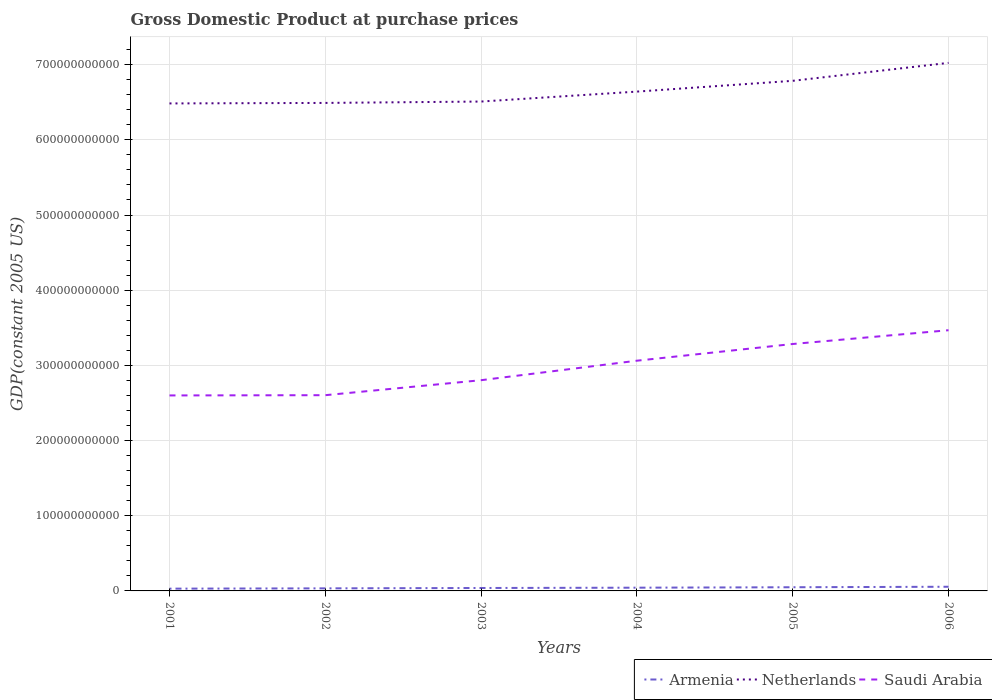Across all years, what is the maximum GDP at purchase prices in Armenia?
Make the answer very short. 3.02e+09. What is the total GDP at purchase prices in Armenia in the graph?
Offer a terse response. -8.87e+08. What is the difference between the highest and the second highest GDP at purchase prices in Saudi Arabia?
Provide a short and direct response. 8.68e+1. Is the GDP at purchase prices in Netherlands strictly greater than the GDP at purchase prices in Armenia over the years?
Ensure brevity in your answer.  No. How many lines are there?
Keep it short and to the point. 3. How many years are there in the graph?
Your response must be concise. 6. What is the difference between two consecutive major ticks on the Y-axis?
Keep it short and to the point. 1.00e+11. Does the graph contain any zero values?
Offer a terse response. No. Does the graph contain grids?
Provide a succinct answer. Yes. How many legend labels are there?
Your response must be concise. 3. How are the legend labels stacked?
Offer a very short reply. Horizontal. What is the title of the graph?
Give a very brief answer. Gross Domestic Product at purchase prices. Does "Japan" appear as one of the legend labels in the graph?
Your answer should be very brief. No. What is the label or title of the Y-axis?
Ensure brevity in your answer.  GDP(constant 2005 US). What is the GDP(constant 2005 US) in Armenia in 2001?
Make the answer very short. 3.02e+09. What is the GDP(constant 2005 US) in Netherlands in 2001?
Keep it short and to the point. 6.48e+11. What is the GDP(constant 2005 US) of Saudi Arabia in 2001?
Your answer should be compact. 2.60e+11. What is the GDP(constant 2005 US) of Armenia in 2002?
Your response must be concise. 3.42e+09. What is the GDP(constant 2005 US) in Netherlands in 2002?
Provide a short and direct response. 6.49e+11. What is the GDP(constant 2005 US) in Saudi Arabia in 2002?
Offer a very short reply. 2.60e+11. What is the GDP(constant 2005 US) of Armenia in 2003?
Provide a short and direct response. 3.90e+09. What is the GDP(constant 2005 US) of Netherlands in 2003?
Keep it short and to the point. 6.51e+11. What is the GDP(constant 2005 US) in Saudi Arabia in 2003?
Provide a short and direct response. 2.80e+11. What is the GDP(constant 2005 US) in Armenia in 2004?
Provide a short and direct response. 4.30e+09. What is the GDP(constant 2005 US) in Netherlands in 2004?
Your answer should be compact. 6.64e+11. What is the GDP(constant 2005 US) of Saudi Arabia in 2004?
Make the answer very short. 3.06e+11. What is the GDP(constant 2005 US) in Armenia in 2005?
Provide a succinct answer. 4.90e+09. What is the GDP(constant 2005 US) in Netherlands in 2005?
Keep it short and to the point. 6.79e+11. What is the GDP(constant 2005 US) in Saudi Arabia in 2005?
Offer a very short reply. 3.28e+11. What is the GDP(constant 2005 US) in Armenia in 2006?
Your answer should be very brief. 5.55e+09. What is the GDP(constant 2005 US) of Netherlands in 2006?
Give a very brief answer. 7.02e+11. What is the GDP(constant 2005 US) of Saudi Arabia in 2006?
Offer a very short reply. 3.47e+11. Across all years, what is the maximum GDP(constant 2005 US) of Armenia?
Your response must be concise. 5.55e+09. Across all years, what is the maximum GDP(constant 2005 US) of Netherlands?
Keep it short and to the point. 7.02e+11. Across all years, what is the maximum GDP(constant 2005 US) in Saudi Arabia?
Give a very brief answer. 3.47e+11. Across all years, what is the minimum GDP(constant 2005 US) in Armenia?
Provide a succinct answer. 3.02e+09. Across all years, what is the minimum GDP(constant 2005 US) of Netherlands?
Provide a short and direct response. 6.48e+11. Across all years, what is the minimum GDP(constant 2005 US) of Saudi Arabia?
Provide a short and direct response. 2.60e+11. What is the total GDP(constant 2005 US) of Armenia in the graph?
Provide a short and direct response. 2.51e+1. What is the total GDP(constant 2005 US) of Netherlands in the graph?
Ensure brevity in your answer.  3.99e+12. What is the total GDP(constant 2005 US) of Saudi Arabia in the graph?
Your answer should be very brief. 1.78e+12. What is the difference between the GDP(constant 2005 US) in Armenia in 2001 and that in 2002?
Your response must be concise. -3.98e+08. What is the difference between the GDP(constant 2005 US) in Netherlands in 2001 and that in 2002?
Ensure brevity in your answer.  -6.72e+08. What is the difference between the GDP(constant 2005 US) in Saudi Arabia in 2001 and that in 2002?
Provide a succinct answer. -3.32e+08. What is the difference between the GDP(constant 2005 US) of Armenia in 2001 and that in 2003?
Your answer should be very brief. -8.78e+08. What is the difference between the GDP(constant 2005 US) in Netherlands in 2001 and that in 2003?
Keep it short and to the point. -2.51e+09. What is the difference between the GDP(constant 2005 US) in Saudi Arabia in 2001 and that in 2003?
Your response must be concise. -2.03e+1. What is the difference between the GDP(constant 2005 US) in Armenia in 2001 and that in 2004?
Provide a short and direct response. -1.29e+09. What is the difference between the GDP(constant 2005 US) of Netherlands in 2001 and that in 2004?
Ensure brevity in your answer.  -1.57e+1. What is the difference between the GDP(constant 2005 US) in Saudi Arabia in 2001 and that in 2004?
Your answer should be very brief. -4.62e+1. What is the difference between the GDP(constant 2005 US) in Armenia in 2001 and that in 2005?
Make the answer very short. -1.88e+09. What is the difference between the GDP(constant 2005 US) of Netherlands in 2001 and that in 2005?
Your answer should be compact. -3.01e+1. What is the difference between the GDP(constant 2005 US) in Saudi Arabia in 2001 and that in 2005?
Your answer should be very brief. -6.84e+1. What is the difference between the GDP(constant 2005 US) in Armenia in 2001 and that in 2006?
Offer a terse response. -2.53e+09. What is the difference between the GDP(constant 2005 US) in Netherlands in 2001 and that in 2006?
Make the answer very short. -5.40e+1. What is the difference between the GDP(constant 2005 US) in Saudi Arabia in 2001 and that in 2006?
Offer a terse response. -8.68e+1. What is the difference between the GDP(constant 2005 US) of Armenia in 2002 and that in 2003?
Make the answer very short. -4.80e+08. What is the difference between the GDP(constant 2005 US) of Netherlands in 2002 and that in 2003?
Provide a succinct answer. -1.84e+09. What is the difference between the GDP(constant 2005 US) in Saudi Arabia in 2002 and that in 2003?
Ensure brevity in your answer.  -1.99e+1. What is the difference between the GDP(constant 2005 US) in Armenia in 2002 and that in 2004?
Keep it short and to the point. -8.87e+08. What is the difference between the GDP(constant 2005 US) of Netherlands in 2002 and that in 2004?
Provide a succinct answer. -1.51e+1. What is the difference between the GDP(constant 2005 US) of Saudi Arabia in 2002 and that in 2004?
Give a very brief answer. -4.59e+1. What is the difference between the GDP(constant 2005 US) in Armenia in 2002 and that in 2005?
Give a very brief answer. -1.48e+09. What is the difference between the GDP(constant 2005 US) in Netherlands in 2002 and that in 2005?
Your response must be concise. -2.94e+1. What is the difference between the GDP(constant 2005 US) of Saudi Arabia in 2002 and that in 2005?
Offer a terse response. -6.81e+1. What is the difference between the GDP(constant 2005 US) in Armenia in 2002 and that in 2006?
Offer a terse response. -2.13e+09. What is the difference between the GDP(constant 2005 US) in Netherlands in 2002 and that in 2006?
Keep it short and to the point. -5.33e+1. What is the difference between the GDP(constant 2005 US) in Saudi Arabia in 2002 and that in 2006?
Offer a terse response. -8.64e+1. What is the difference between the GDP(constant 2005 US) in Armenia in 2003 and that in 2004?
Your answer should be compact. -4.08e+08. What is the difference between the GDP(constant 2005 US) of Netherlands in 2003 and that in 2004?
Keep it short and to the point. -1.32e+1. What is the difference between the GDP(constant 2005 US) in Saudi Arabia in 2003 and that in 2004?
Your answer should be compact. -2.59e+1. What is the difference between the GDP(constant 2005 US) in Armenia in 2003 and that in 2005?
Give a very brief answer. -1.00e+09. What is the difference between the GDP(constant 2005 US) in Netherlands in 2003 and that in 2005?
Your answer should be compact. -2.76e+1. What is the difference between the GDP(constant 2005 US) in Saudi Arabia in 2003 and that in 2005?
Your answer should be compact. -4.82e+1. What is the difference between the GDP(constant 2005 US) in Armenia in 2003 and that in 2006?
Make the answer very short. -1.65e+09. What is the difference between the GDP(constant 2005 US) of Netherlands in 2003 and that in 2006?
Your answer should be very brief. -5.14e+1. What is the difference between the GDP(constant 2005 US) of Saudi Arabia in 2003 and that in 2006?
Your answer should be very brief. -6.65e+1. What is the difference between the GDP(constant 2005 US) in Armenia in 2004 and that in 2005?
Offer a terse response. -5.97e+08. What is the difference between the GDP(constant 2005 US) in Netherlands in 2004 and that in 2005?
Your answer should be very brief. -1.43e+1. What is the difference between the GDP(constant 2005 US) in Saudi Arabia in 2004 and that in 2005?
Your response must be concise. -2.22e+1. What is the difference between the GDP(constant 2005 US) in Armenia in 2004 and that in 2006?
Your response must be concise. -1.24e+09. What is the difference between the GDP(constant 2005 US) of Netherlands in 2004 and that in 2006?
Keep it short and to the point. -3.82e+1. What is the difference between the GDP(constant 2005 US) in Saudi Arabia in 2004 and that in 2006?
Provide a succinct answer. -4.05e+1. What is the difference between the GDP(constant 2005 US) of Armenia in 2005 and that in 2006?
Give a very brief answer. -6.47e+08. What is the difference between the GDP(constant 2005 US) in Netherlands in 2005 and that in 2006?
Keep it short and to the point. -2.39e+1. What is the difference between the GDP(constant 2005 US) in Saudi Arabia in 2005 and that in 2006?
Provide a succinct answer. -1.83e+1. What is the difference between the GDP(constant 2005 US) of Armenia in 2001 and the GDP(constant 2005 US) of Netherlands in 2002?
Give a very brief answer. -6.46e+11. What is the difference between the GDP(constant 2005 US) in Armenia in 2001 and the GDP(constant 2005 US) in Saudi Arabia in 2002?
Provide a short and direct response. -2.57e+11. What is the difference between the GDP(constant 2005 US) in Netherlands in 2001 and the GDP(constant 2005 US) in Saudi Arabia in 2002?
Your answer should be very brief. 3.88e+11. What is the difference between the GDP(constant 2005 US) in Armenia in 2001 and the GDP(constant 2005 US) in Netherlands in 2003?
Offer a terse response. -6.48e+11. What is the difference between the GDP(constant 2005 US) in Armenia in 2001 and the GDP(constant 2005 US) in Saudi Arabia in 2003?
Ensure brevity in your answer.  -2.77e+11. What is the difference between the GDP(constant 2005 US) of Netherlands in 2001 and the GDP(constant 2005 US) of Saudi Arabia in 2003?
Provide a short and direct response. 3.68e+11. What is the difference between the GDP(constant 2005 US) of Armenia in 2001 and the GDP(constant 2005 US) of Netherlands in 2004?
Make the answer very short. -6.61e+11. What is the difference between the GDP(constant 2005 US) of Armenia in 2001 and the GDP(constant 2005 US) of Saudi Arabia in 2004?
Your answer should be compact. -3.03e+11. What is the difference between the GDP(constant 2005 US) of Netherlands in 2001 and the GDP(constant 2005 US) of Saudi Arabia in 2004?
Make the answer very short. 3.42e+11. What is the difference between the GDP(constant 2005 US) in Armenia in 2001 and the GDP(constant 2005 US) in Netherlands in 2005?
Give a very brief answer. -6.76e+11. What is the difference between the GDP(constant 2005 US) in Armenia in 2001 and the GDP(constant 2005 US) in Saudi Arabia in 2005?
Provide a short and direct response. -3.25e+11. What is the difference between the GDP(constant 2005 US) in Netherlands in 2001 and the GDP(constant 2005 US) in Saudi Arabia in 2005?
Offer a terse response. 3.20e+11. What is the difference between the GDP(constant 2005 US) of Armenia in 2001 and the GDP(constant 2005 US) of Netherlands in 2006?
Your answer should be very brief. -6.99e+11. What is the difference between the GDP(constant 2005 US) of Armenia in 2001 and the GDP(constant 2005 US) of Saudi Arabia in 2006?
Give a very brief answer. -3.44e+11. What is the difference between the GDP(constant 2005 US) of Netherlands in 2001 and the GDP(constant 2005 US) of Saudi Arabia in 2006?
Your answer should be very brief. 3.02e+11. What is the difference between the GDP(constant 2005 US) of Armenia in 2002 and the GDP(constant 2005 US) of Netherlands in 2003?
Make the answer very short. -6.48e+11. What is the difference between the GDP(constant 2005 US) of Armenia in 2002 and the GDP(constant 2005 US) of Saudi Arabia in 2003?
Make the answer very short. -2.77e+11. What is the difference between the GDP(constant 2005 US) in Netherlands in 2002 and the GDP(constant 2005 US) in Saudi Arabia in 2003?
Provide a succinct answer. 3.69e+11. What is the difference between the GDP(constant 2005 US) of Armenia in 2002 and the GDP(constant 2005 US) of Netherlands in 2004?
Your response must be concise. -6.61e+11. What is the difference between the GDP(constant 2005 US) in Armenia in 2002 and the GDP(constant 2005 US) in Saudi Arabia in 2004?
Offer a terse response. -3.03e+11. What is the difference between the GDP(constant 2005 US) of Netherlands in 2002 and the GDP(constant 2005 US) of Saudi Arabia in 2004?
Provide a short and direct response. 3.43e+11. What is the difference between the GDP(constant 2005 US) of Armenia in 2002 and the GDP(constant 2005 US) of Netherlands in 2005?
Keep it short and to the point. -6.75e+11. What is the difference between the GDP(constant 2005 US) in Armenia in 2002 and the GDP(constant 2005 US) in Saudi Arabia in 2005?
Make the answer very short. -3.25e+11. What is the difference between the GDP(constant 2005 US) of Netherlands in 2002 and the GDP(constant 2005 US) of Saudi Arabia in 2005?
Your response must be concise. 3.21e+11. What is the difference between the GDP(constant 2005 US) in Armenia in 2002 and the GDP(constant 2005 US) in Netherlands in 2006?
Make the answer very short. -6.99e+11. What is the difference between the GDP(constant 2005 US) of Armenia in 2002 and the GDP(constant 2005 US) of Saudi Arabia in 2006?
Provide a succinct answer. -3.43e+11. What is the difference between the GDP(constant 2005 US) in Netherlands in 2002 and the GDP(constant 2005 US) in Saudi Arabia in 2006?
Offer a very short reply. 3.02e+11. What is the difference between the GDP(constant 2005 US) of Armenia in 2003 and the GDP(constant 2005 US) of Netherlands in 2004?
Offer a terse response. -6.60e+11. What is the difference between the GDP(constant 2005 US) in Armenia in 2003 and the GDP(constant 2005 US) in Saudi Arabia in 2004?
Your answer should be compact. -3.02e+11. What is the difference between the GDP(constant 2005 US) in Netherlands in 2003 and the GDP(constant 2005 US) in Saudi Arabia in 2004?
Your answer should be compact. 3.45e+11. What is the difference between the GDP(constant 2005 US) in Armenia in 2003 and the GDP(constant 2005 US) in Netherlands in 2005?
Offer a very short reply. -6.75e+11. What is the difference between the GDP(constant 2005 US) of Armenia in 2003 and the GDP(constant 2005 US) of Saudi Arabia in 2005?
Your response must be concise. -3.25e+11. What is the difference between the GDP(constant 2005 US) of Netherlands in 2003 and the GDP(constant 2005 US) of Saudi Arabia in 2005?
Your answer should be very brief. 3.23e+11. What is the difference between the GDP(constant 2005 US) in Armenia in 2003 and the GDP(constant 2005 US) in Netherlands in 2006?
Provide a succinct answer. -6.99e+11. What is the difference between the GDP(constant 2005 US) in Armenia in 2003 and the GDP(constant 2005 US) in Saudi Arabia in 2006?
Provide a short and direct response. -3.43e+11. What is the difference between the GDP(constant 2005 US) in Netherlands in 2003 and the GDP(constant 2005 US) in Saudi Arabia in 2006?
Offer a very short reply. 3.04e+11. What is the difference between the GDP(constant 2005 US) of Armenia in 2004 and the GDP(constant 2005 US) of Netherlands in 2005?
Keep it short and to the point. -6.74e+11. What is the difference between the GDP(constant 2005 US) in Armenia in 2004 and the GDP(constant 2005 US) in Saudi Arabia in 2005?
Offer a terse response. -3.24e+11. What is the difference between the GDP(constant 2005 US) of Netherlands in 2004 and the GDP(constant 2005 US) of Saudi Arabia in 2005?
Give a very brief answer. 3.36e+11. What is the difference between the GDP(constant 2005 US) in Armenia in 2004 and the GDP(constant 2005 US) in Netherlands in 2006?
Provide a short and direct response. -6.98e+11. What is the difference between the GDP(constant 2005 US) of Armenia in 2004 and the GDP(constant 2005 US) of Saudi Arabia in 2006?
Keep it short and to the point. -3.42e+11. What is the difference between the GDP(constant 2005 US) in Netherlands in 2004 and the GDP(constant 2005 US) in Saudi Arabia in 2006?
Offer a terse response. 3.17e+11. What is the difference between the GDP(constant 2005 US) in Armenia in 2005 and the GDP(constant 2005 US) in Netherlands in 2006?
Provide a succinct answer. -6.98e+11. What is the difference between the GDP(constant 2005 US) of Armenia in 2005 and the GDP(constant 2005 US) of Saudi Arabia in 2006?
Offer a very short reply. -3.42e+11. What is the difference between the GDP(constant 2005 US) of Netherlands in 2005 and the GDP(constant 2005 US) of Saudi Arabia in 2006?
Your response must be concise. 3.32e+11. What is the average GDP(constant 2005 US) in Armenia per year?
Your response must be concise. 4.18e+09. What is the average GDP(constant 2005 US) of Netherlands per year?
Offer a very short reply. 6.66e+11. What is the average GDP(constant 2005 US) of Saudi Arabia per year?
Make the answer very short. 2.97e+11. In the year 2001, what is the difference between the GDP(constant 2005 US) in Armenia and GDP(constant 2005 US) in Netherlands?
Your response must be concise. -6.45e+11. In the year 2001, what is the difference between the GDP(constant 2005 US) of Armenia and GDP(constant 2005 US) of Saudi Arabia?
Make the answer very short. -2.57e+11. In the year 2001, what is the difference between the GDP(constant 2005 US) in Netherlands and GDP(constant 2005 US) in Saudi Arabia?
Make the answer very short. 3.88e+11. In the year 2002, what is the difference between the GDP(constant 2005 US) in Armenia and GDP(constant 2005 US) in Netherlands?
Ensure brevity in your answer.  -6.46e+11. In the year 2002, what is the difference between the GDP(constant 2005 US) of Armenia and GDP(constant 2005 US) of Saudi Arabia?
Ensure brevity in your answer.  -2.57e+11. In the year 2002, what is the difference between the GDP(constant 2005 US) of Netherlands and GDP(constant 2005 US) of Saudi Arabia?
Provide a succinct answer. 3.89e+11. In the year 2003, what is the difference between the GDP(constant 2005 US) of Armenia and GDP(constant 2005 US) of Netherlands?
Make the answer very short. -6.47e+11. In the year 2003, what is the difference between the GDP(constant 2005 US) in Armenia and GDP(constant 2005 US) in Saudi Arabia?
Your response must be concise. -2.76e+11. In the year 2003, what is the difference between the GDP(constant 2005 US) of Netherlands and GDP(constant 2005 US) of Saudi Arabia?
Make the answer very short. 3.71e+11. In the year 2004, what is the difference between the GDP(constant 2005 US) in Armenia and GDP(constant 2005 US) in Netherlands?
Ensure brevity in your answer.  -6.60e+11. In the year 2004, what is the difference between the GDP(constant 2005 US) in Armenia and GDP(constant 2005 US) in Saudi Arabia?
Your answer should be very brief. -3.02e+11. In the year 2004, what is the difference between the GDP(constant 2005 US) of Netherlands and GDP(constant 2005 US) of Saudi Arabia?
Give a very brief answer. 3.58e+11. In the year 2005, what is the difference between the GDP(constant 2005 US) of Armenia and GDP(constant 2005 US) of Netherlands?
Make the answer very short. -6.74e+11. In the year 2005, what is the difference between the GDP(constant 2005 US) in Armenia and GDP(constant 2005 US) in Saudi Arabia?
Provide a succinct answer. -3.24e+11. In the year 2005, what is the difference between the GDP(constant 2005 US) in Netherlands and GDP(constant 2005 US) in Saudi Arabia?
Your response must be concise. 3.50e+11. In the year 2006, what is the difference between the GDP(constant 2005 US) in Armenia and GDP(constant 2005 US) in Netherlands?
Provide a short and direct response. -6.97e+11. In the year 2006, what is the difference between the GDP(constant 2005 US) in Armenia and GDP(constant 2005 US) in Saudi Arabia?
Make the answer very short. -3.41e+11. In the year 2006, what is the difference between the GDP(constant 2005 US) in Netherlands and GDP(constant 2005 US) in Saudi Arabia?
Make the answer very short. 3.56e+11. What is the ratio of the GDP(constant 2005 US) in Armenia in 2001 to that in 2002?
Keep it short and to the point. 0.88. What is the ratio of the GDP(constant 2005 US) of Netherlands in 2001 to that in 2002?
Keep it short and to the point. 1. What is the ratio of the GDP(constant 2005 US) of Armenia in 2001 to that in 2003?
Give a very brief answer. 0.77. What is the ratio of the GDP(constant 2005 US) in Saudi Arabia in 2001 to that in 2003?
Your answer should be very brief. 0.93. What is the ratio of the GDP(constant 2005 US) of Armenia in 2001 to that in 2004?
Your answer should be compact. 0.7. What is the ratio of the GDP(constant 2005 US) in Netherlands in 2001 to that in 2004?
Your response must be concise. 0.98. What is the ratio of the GDP(constant 2005 US) of Saudi Arabia in 2001 to that in 2004?
Make the answer very short. 0.85. What is the ratio of the GDP(constant 2005 US) of Armenia in 2001 to that in 2005?
Ensure brevity in your answer.  0.62. What is the ratio of the GDP(constant 2005 US) of Netherlands in 2001 to that in 2005?
Offer a terse response. 0.96. What is the ratio of the GDP(constant 2005 US) in Saudi Arabia in 2001 to that in 2005?
Provide a succinct answer. 0.79. What is the ratio of the GDP(constant 2005 US) of Armenia in 2001 to that in 2006?
Your answer should be very brief. 0.54. What is the ratio of the GDP(constant 2005 US) in Netherlands in 2001 to that in 2006?
Your response must be concise. 0.92. What is the ratio of the GDP(constant 2005 US) of Saudi Arabia in 2001 to that in 2006?
Make the answer very short. 0.75. What is the ratio of the GDP(constant 2005 US) in Armenia in 2002 to that in 2003?
Give a very brief answer. 0.88. What is the ratio of the GDP(constant 2005 US) in Saudi Arabia in 2002 to that in 2003?
Your response must be concise. 0.93. What is the ratio of the GDP(constant 2005 US) in Armenia in 2002 to that in 2004?
Give a very brief answer. 0.79. What is the ratio of the GDP(constant 2005 US) in Netherlands in 2002 to that in 2004?
Provide a short and direct response. 0.98. What is the ratio of the GDP(constant 2005 US) in Saudi Arabia in 2002 to that in 2004?
Provide a short and direct response. 0.85. What is the ratio of the GDP(constant 2005 US) of Armenia in 2002 to that in 2005?
Make the answer very short. 0.7. What is the ratio of the GDP(constant 2005 US) of Netherlands in 2002 to that in 2005?
Offer a terse response. 0.96. What is the ratio of the GDP(constant 2005 US) in Saudi Arabia in 2002 to that in 2005?
Offer a very short reply. 0.79. What is the ratio of the GDP(constant 2005 US) of Armenia in 2002 to that in 2006?
Give a very brief answer. 0.62. What is the ratio of the GDP(constant 2005 US) of Netherlands in 2002 to that in 2006?
Provide a succinct answer. 0.92. What is the ratio of the GDP(constant 2005 US) of Saudi Arabia in 2002 to that in 2006?
Make the answer very short. 0.75. What is the ratio of the GDP(constant 2005 US) in Armenia in 2003 to that in 2004?
Offer a very short reply. 0.91. What is the ratio of the GDP(constant 2005 US) in Netherlands in 2003 to that in 2004?
Make the answer very short. 0.98. What is the ratio of the GDP(constant 2005 US) of Saudi Arabia in 2003 to that in 2004?
Give a very brief answer. 0.92. What is the ratio of the GDP(constant 2005 US) of Armenia in 2003 to that in 2005?
Your response must be concise. 0.8. What is the ratio of the GDP(constant 2005 US) of Netherlands in 2003 to that in 2005?
Keep it short and to the point. 0.96. What is the ratio of the GDP(constant 2005 US) of Saudi Arabia in 2003 to that in 2005?
Ensure brevity in your answer.  0.85. What is the ratio of the GDP(constant 2005 US) in Armenia in 2003 to that in 2006?
Provide a short and direct response. 0.7. What is the ratio of the GDP(constant 2005 US) of Netherlands in 2003 to that in 2006?
Your answer should be very brief. 0.93. What is the ratio of the GDP(constant 2005 US) of Saudi Arabia in 2003 to that in 2006?
Provide a short and direct response. 0.81. What is the ratio of the GDP(constant 2005 US) of Armenia in 2004 to that in 2005?
Your answer should be very brief. 0.88. What is the ratio of the GDP(constant 2005 US) of Netherlands in 2004 to that in 2005?
Provide a short and direct response. 0.98. What is the ratio of the GDP(constant 2005 US) in Saudi Arabia in 2004 to that in 2005?
Provide a succinct answer. 0.93. What is the ratio of the GDP(constant 2005 US) in Armenia in 2004 to that in 2006?
Your response must be concise. 0.78. What is the ratio of the GDP(constant 2005 US) of Netherlands in 2004 to that in 2006?
Ensure brevity in your answer.  0.95. What is the ratio of the GDP(constant 2005 US) of Saudi Arabia in 2004 to that in 2006?
Provide a short and direct response. 0.88. What is the ratio of the GDP(constant 2005 US) of Armenia in 2005 to that in 2006?
Offer a very short reply. 0.88. What is the ratio of the GDP(constant 2005 US) of Netherlands in 2005 to that in 2006?
Ensure brevity in your answer.  0.97. What is the ratio of the GDP(constant 2005 US) of Saudi Arabia in 2005 to that in 2006?
Provide a succinct answer. 0.95. What is the difference between the highest and the second highest GDP(constant 2005 US) of Armenia?
Keep it short and to the point. 6.47e+08. What is the difference between the highest and the second highest GDP(constant 2005 US) of Netherlands?
Keep it short and to the point. 2.39e+1. What is the difference between the highest and the second highest GDP(constant 2005 US) of Saudi Arabia?
Your answer should be very brief. 1.83e+1. What is the difference between the highest and the lowest GDP(constant 2005 US) in Armenia?
Your answer should be very brief. 2.53e+09. What is the difference between the highest and the lowest GDP(constant 2005 US) of Netherlands?
Ensure brevity in your answer.  5.40e+1. What is the difference between the highest and the lowest GDP(constant 2005 US) in Saudi Arabia?
Offer a terse response. 8.68e+1. 